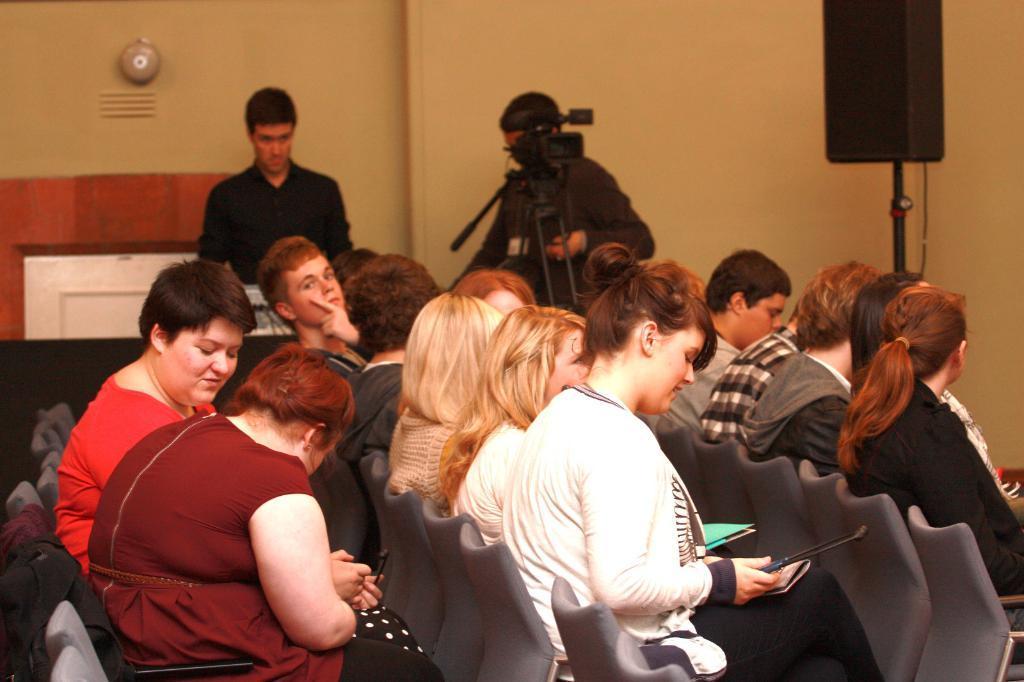Please provide a concise description of this image. In this image there are a few people sitting on the chair, a few are holding files and other objects in their hands, behind them there are two people standing, there are a camera stand and a speaker. In the background there is a wall. 